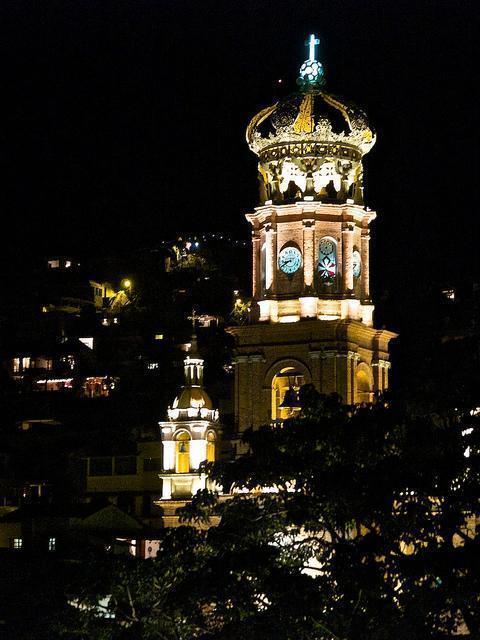What is on the top of the building?
Select the correct answer and articulate reasoning with the following format: 'Answer: answer
Rationale: rationale.'
Options: Cross, human, weathervane, bird. Answer: cross.
Rationale: There is a cross on the top of the building that is lit up. 